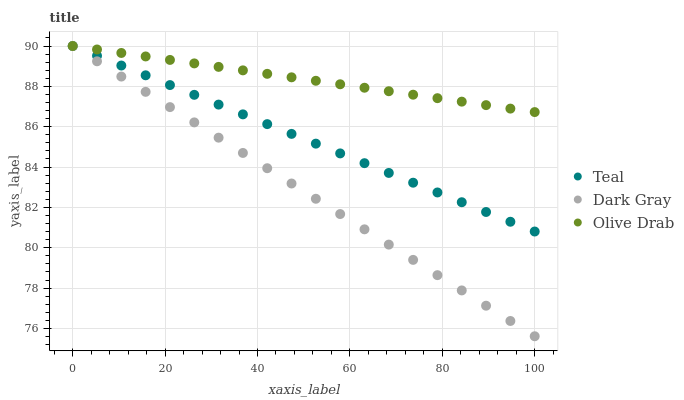Does Dark Gray have the minimum area under the curve?
Answer yes or no. Yes. Does Olive Drab have the maximum area under the curve?
Answer yes or no. Yes. Does Teal have the minimum area under the curve?
Answer yes or no. No. Does Teal have the maximum area under the curve?
Answer yes or no. No. Is Teal the smoothest?
Answer yes or no. Yes. Is Olive Drab the roughest?
Answer yes or no. Yes. Is Olive Drab the smoothest?
Answer yes or no. No. Is Teal the roughest?
Answer yes or no. No. Does Dark Gray have the lowest value?
Answer yes or no. Yes. Does Teal have the lowest value?
Answer yes or no. No. Does Teal have the highest value?
Answer yes or no. Yes. Does Dark Gray intersect Teal?
Answer yes or no. Yes. Is Dark Gray less than Teal?
Answer yes or no. No. Is Dark Gray greater than Teal?
Answer yes or no. No. 